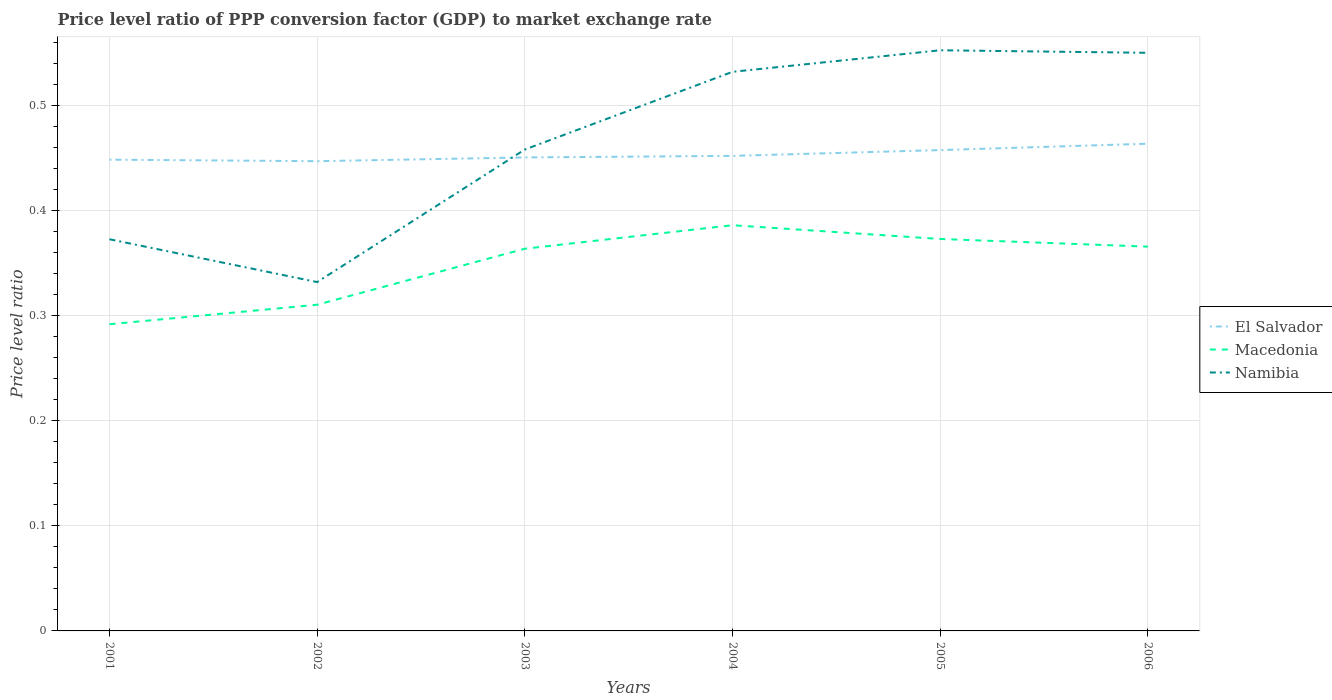Does the line corresponding to Namibia intersect with the line corresponding to El Salvador?
Provide a short and direct response. Yes. Across all years, what is the maximum price level ratio in Macedonia?
Ensure brevity in your answer.  0.29. In which year was the price level ratio in Namibia maximum?
Your answer should be very brief. 2002. What is the total price level ratio in Namibia in the graph?
Make the answer very short. -0.09. What is the difference between the highest and the second highest price level ratio in Macedonia?
Make the answer very short. 0.09. Is the price level ratio in Macedonia strictly greater than the price level ratio in El Salvador over the years?
Provide a short and direct response. Yes. How many years are there in the graph?
Your answer should be compact. 6. Are the values on the major ticks of Y-axis written in scientific E-notation?
Offer a very short reply. No. Does the graph contain grids?
Ensure brevity in your answer.  Yes. How are the legend labels stacked?
Your response must be concise. Vertical. What is the title of the graph?
Ensure brevity in your answer.  Price level ratio of PPP conversion factor (GDP) to market exchange rate. Does "China" appear as one of the legend labels in the graph?
Keep it short and to the point. No. What is the label or title of the Y-axis?
Offer a very short reply. Price level ratio. What is the Price level ratio in El Salvador in 2001?
Your response must be concise. 0.45. What is the Price level ratio in Macedonia in 2001?
Your answer should be very brief. 0.29. What is the Price level ratio of Namibia in 2001?
Provide a short and direct response. 0.37. What is the Price level ratio of El Salvador in 2002?
Ensure brevity in your answer.  0.45. What is the Price level ratio in Macedonia in 2002?
Ensure brevity in your answer.  0.31. What is the Price level ratio of Namibia in 2002?
Provide a succinct answer. 0.33. What is the Price level ratio of El Salvador in 2003?
Your answer should be very brief. 0.45. What is the Price level ratio in Macedonia in 2003?
Keep it short and to the point. 0.36. What is the Price level ratio in Namibia in 2003?
Ensure brevity in your answer.  0.46. What is the Price level ratio in El Salvador in 2004?
Provide a succinct answer. 0.45. What is the Price level ratio in Macedonia in 2004?
Your answer should be very brief. 0.39. What is the Price level ratio of Namibia in 2004?
Offer a very short reply. 0.53. What is the Price level ratio of El Salvador in 2005?
Provide a short and direct response. 0.46. What is the Price level ratio of Macedonia in 2005?
Your answer should be very brief. 0.37. What is the Price level ratio of Namibia in 2005?
Give a very brief answer. 0.55. What is the Price level ratio in El Salvador in 2006?
Provide a succinct answer. 0.46. What is the Price level ratio of Macedonia in 2006?
Your response must be concise. 0.37. What is the Price level ratio in Namibia in 2006?
Keep it short and to the point. 0.55. Across all years, what is the maximum Price level ratio in El Salvador?
Your answer should be compact. 0.46. Across all years, what is the maximum Price level ratio in Macedonia?
Provide a succinct answer. 0.39. Across all years, what is the maximum Price level ratio in Namibia?
Make the answer very short. 0.55. Across all years, what is the minimum Price level ratio of El Salvador?
Your answer should be compact. 0.45. Across all years, what is the minimum Price level ratio of Macedonia?
Offer a very short reply. 0.29. Across all years, what is the minimum Price level ratio of Namibia?
Offer a very short reply. 0.33. What is the total Price level ratio in El Salvador in the graph?
Your answer should be very brief. 2.72. What is the total Price level ratio of Macedonia in the graph?
Your answer should be compact. 2.09. What is the total Price level ratio of Namibia in the graph?
Ensure brevity in your answer.  2.8. What is the difference between the Price level ratio in El Salvador in 2001 and that in 2002?
Your answer should be compact. 0. What is the difference between the Price level ratio in Macedonia in 2001 and that in 2002?
Offer a very short reply. -0.02. What is the difference between the Price level ratio of Namibia in 2001 and that in 2002?
Offer a terse response. 0.04. What is the difference between the Price level ratio of El Salvador in 2001 and that in 2003?
Ensure brevity in your answer.  -0. What is the difference between the Price level ratio in Macedonia in 2001 and that in 2003?
Provide a succinct answer. -0.07. What is the difference between the Price level ratio in Namibia in 2001 and that in 2003?
Offer a terse response. -0.09. What is the difference between the Price level ratio of El Salvador in 2001 and that in 2004?
Your response must be concise. -0. What is the difference between the Price level ratio in Macedonia in 2001 and that in 2004?
Your answer should be very brief. -0.09. What is the difference between the Price level ratio of Namibia in 2001 and that in 2004?
Keep it short and to the point. -0.16. What is the difference between the Price level ratio in El Salvador in 2001 and that in 2005?
Make the answer very short. -0.01. What is the difference between the Price level ratio of Macedonia in 2001 and that in 2005?
Offer a terse response. -0.08. What is the difference between the Price level ratio of Namibia in 2001 and that in 2005?
Keep it short and to the point. -0.18. What is the difference between the Price level ratio in El Salvador in 2001 and that in 2006?
Keep it short and to the point. -0.02. What is the difference between the Price level ratio in Macedonia in 2001 and that in 2006?
Provide a succinct answer. -0.07. What is the difference between the Price level ratio of Namibia in 2001 and that in 2006?
Your response must be concise. -0.18. What is the difference between the Price level ratio of El Salvador in 2002 and that in 2003?
Ensure brevity in your answer.  -0. What is the difference between the Price level ratio of Macedonia in 2002 and that in 2003?
Your answer should be very brief. -0.05. What is the difference between the Price level ratio of Namibia in 2002 and that in 2003?
Your answer should be compact. -0.13. What is the difference between the Price level ratio in El Salvador in 2002 and that in 2004?
Ensure brevity in your answer.  -0.01. What is the difference between the Price level ratio of Macedonia in 2002 and that in 2004?
Give a very brief answer. -0.08. What is the difference between the Price level ratio of Namibia in 2002 and that in 2004?
Provide a succinct answer. -0.2. What is the difference between the Price level ratio in El Salvador in 2002 and that in 2005?
Offer a terse response. -0.01. What is the difference between the Price level ratio of Macedonia in 2002 and that in 2005?
Provide a succinct answer. -0.06. What is the difference between the Price level ratio of Namibia in 2002 and that in 2005?
Your answer should be compact. -0.22. What is the difference between the Price level ratio of El Salvador in 2002 and that in 2006?
Provide a short and direct response. -0.02. What is the difference between the Price level ratio of Macedonia in 2002 and that in 2006?
Your answer should be very brief. -0.06. What is the difference between the Price level ratio of Namibia in 2002 and that in 2006?
Offer a very short reply. -0.22. What is the difference between the Price level ratio in El Salvador in 2003 and that in 2004?
Ensure brevity in your answer.  -0. What is the difference between the Price level ratio of Macedonia in 2003 and that in 2004?
Ensure brevity in your answer.  -0.02. What is the difference between the Price level ratio in Namibia in 2003 and that in 2004?
Give a very brief answer. -0.07. What is the difference between the Price level ratio in El Salvador in 2003 and that in 2005?
Keep it short and to the point. -0.01. What is the difference between the Price level ratio of Macedonia in 2003 and that in 2005?
Your answer should be compact. -0.01. What is the difference between the Price level ratio in Namibia in 2003 and that in 2005?
Give a very brief answer. -0.09. What is the difference between the Price level ratio of El Salvador in 2003 and that in 2006?
Offer a very short reply. -0.01. What is the difference between the Price level ratio in Macedonia in 2003 and that in 2006?
Provide a short and direct response. -0. What is the difference between the Price level ratio of Namibia in 2003 and that in 2006?
Your answer should be very brief. -0.09. What is the difference between the Price level ratio in El Salvador in 2004 and that in 2005?
Offer a very short reply. -0.01. What is the difference between the Price level ratio in Macedonia in 2004 and that in 2005?
Your answer should be compact. 0.01. What is the difference between the Price level ratio of Namibia in 2004 and that in 2005?
Your answer should be very brief. -0.02. What is the difference between the Price level ratio in El Salvador in 2004 and that in 2006?
Provide a succinct answer. -0.01. What is the difference between the Price level ratio of Macedonia in 2004 and that in 2006?
Give a very brief answer. 0.02. What is the difference between the Price level ratio of Namibia in 2004 and that in 2006?
Keep it short and to the point. -0.02. What is the difference between the Price level ratio of El Salvador in 2005 and that in 2006?
Offer a terse response. -0.01. What is the difference between the Price level ratio of Macedonia in 2005 and that in 2006?
Provide a short and direct response. 0.01. What is the difference between the Price level ratio in Namibia in 2005 and that in 2006?
Give a very brief answer. 0. What is the difference between the Price level ratio in El Salvador in 2001 and the Price level ratio in Macedonia in 2002?
Offer a very short reply. 0.14. What is the difference between the Price level ratio of El Salvador in 2001 and the Price level ratio of Namibia in 2002?
Your response must be concise. 0.12. What is the difference between the Price level ratio in Macedonia in 2001 and the Price level ratio in Namibia in 2002?
Your response must be concise. -0.04. What is the difference between the Price level ratio in El Salvador in 2001 and the Price level ratio in Macedonia in 2003?
Offer a very short reply. 0.08. What is the difference between the Price level ratio in El Salvador in 2001 and the Price level ratio in Namibia in 2003?
Offer a very short reply. -0.01. What is the difference between the Price level ratio in Macedonia in 2001 and the Price level ratio in Namibia in 2003?
Offer a very short reply. -0.17. What is the difference between the Price level ratio in El Salvador in 2001 and the Price level ratio in Macedonia in 2004?
Keep it short and to the point. 0.06. What is the difference between the Price level ratio of El Salvador in 2001 and the Price level ratio of Namibia in 2004?
Your answer should be very brief. -0.08. What is the difference between the Price level ratio in Macedonia in 2001 and the Price level ratio in Namibia in 2004?
Provide a short and direct response. -0.24. What is the difference between the Price level ratio in El Salvador in 2001 and the Price level ratio in Macedonia in 2005?
Your answer should be compact. 0.08. What is the difference between the Price level ratio in El Salvador in 2001 and the Price level ratio in Namibia in 2005?
Provide a short and direct response. -0.1. What is the difference between the Price level ratio of Macedonia in 2001 and the Price level ratio of Namibia in 2005?
Provide a short and direct response. -0.26. What is the difference between the Price level ratio of El Salvador in 2001 and the Price level ratio of Macedonia in 2006?
Ensure brevity in your answer.  0.08. What is the difference between the Price level ratio of El Salvador in 2001 and the Price level ratio of Namibia in 2006?
Provide a succinct answer. -0.1. What is the difference between the Price level ratio in Macedonia in 2001 and the Price level ratio in Namibia in 2006?
Offer a terse response. -0.26. What is the difference between the Price level ratio in El Salvador in 2002 and the Price level ratio in Macedonia in 2003?
Offer a very short reply. 0.08. What is the difference between the Price level ratio of El Salvador in 2002 and the Price level ratio of Namibia in 2003?
Give a very brief answer. -0.01. What is the difference between the Price level ratio in Macedonia in 2002 and the Price level ratio in Namibia in 2003?
Make the answer very short. -0.15. What is the difference between the Price level ratio in El Salvador in 2002 and the Price level ratio in Macedonia in 2004?
Ensure brevity in your answer.  0.06. What is the difference between the Price level ratio of El Salvador in 2002 and the Price level ratio of Namibia in 2004?
Provide a short and direct response. -0.09. What is the difference between the Price level ratio of Macedonia in 2002 and the Price level ratio of Namibia in 2004?
Provide a succinct answer. -0.22. What is the difference between the Price level ratio of El Salvador in 2002 and the Price level ratio of Macedonia in 2005?
Your answer should be compact. 0.07. What is the difference between the Price level ratio of El Salvador in 2002 and the Price level ratio of Namibia in 2005?
Your response must be concise. -0.11. What is the difference between the Price level ratio in Macedonia in 2002 and the Price level ratio in Namibia in 2005?
Your answer should be very brief. -0.24. What is the difference between the Price level ratio of El Salvador in 2002 and the Price level ratio of Macedonia in 2006?
Make the answer very short. 0.08. What is the difference between the Price level ratio of El Salvador in 2002 and the Price level ratio of Namibia in 2006?
Ensure brevity in your answer.  -0.1. What is the difference between the Price level ratio in Macedonia in 2002 and the Price level ratio in Namibia in 2006?
Provide a short and direct response. -0.24. What is the difference between the Price level ratio in El Salvador in 2003 and the Price level ratio in Macedonia in 2004?
Ensure brevity in your answer.  0.06. What is the difference between the Price level ratio in El Salvador in 2003 and the Price level ratio in Namibia in 2004?
Give a very brief answer. -0.08. What is the difference between the Price level ratio in Macedonia in 2003 and the Price level ratio in Namibia in 2004?
Your answer should be compact. -0.17. What is the difference between the Price level ratio in El Salvador in 2003 and the Price level ratio in Macedonia in 2005?
Offer a terse response. 0.08. What is the difference between the Price level ratio of El Salvador in 2003 and the Price level ratio of Namibia in 2005?
Your answer should be compact. -0.1. What is the difference between the Price level ratio of Macedonia in 2003 and the Price level ratio of Namibia in 2005?
Offer a very short reply. -0.19. What is the difference between the Price level ratio of El Salvador in 2003 and the Price level ratio of Macedonia in 2006?
Make the answer very short. 0.08. What is the difference between the Price level ratio of El Salvador in 2003 and the Price level ratio of Namibia in 2006?
Keep it short and to the point. -0.1. What is the difference between the Price level ratio of Macedonia in 2003 and the Price level ratio of Namibia in 2006?
Your answer should be compact. -0.19. What is the difference between the Price level ratio in El Salvador in 2004 and the Price level ratio in Macedonia in 2005?
Make the answer very short. 0.08. What is the difference between the Price level ratio in El Salvador in 2004 and the Price level ratio in Namibia in 2005?
Keep it short and to the point. -0.1. What is the difference between the Price level ratio of Macedonia in 2004 and the Price level ratio of Namibia in 2005?
Keep it short and to the point. -0.17. What is the difference between the Price level ratio in El Salvador in 2004 and the Price level ratio in Macedonia in 2006?
Give a very brief answer. 0.09. What is the difference between the Price level ratio of El Salvador in 2004 and the Price level ratio of Namibia in 2006?
Provide a short and direct response. -0.1. What is the difference between the Price level ratio in Macedonia in 2004 and the Price level ratio in Namibia in 2006?
Offer a very short reply. -0.16. What is the difference between the Price level ratio in El Salvador in 2005 and the Price level ratio in Macedonia in 2006?
Your answer should be compact. 0.09. What is the difference between the Price level ratio of El Salvador in 2005 and the Price level ratio of Namibia in 2006?
Your answer should be compact. -0.09. What is the difference between the Price level ratio in Macedonia in 2005 and the Price level ratio in Namibia in 2006?
Your answer should be very brief. -0.18. What is the average Price level ratio of El Salvador per year?
Your answer should be very brief. 0.45. What is the average Price level ratio in Macedonia per year?
Give a very brief answer. 0.35. What is the average Price level ratio of Namibia per year?
Offer a very short reply. 0.47. In the year 2001, what is the difference between the Price level ratio of El Salvador and Price level ratio of Macedonia?
Provide a succinct answer. 0.16. In the year 2001, what is the difference between the Price level ratio in El Salvador and Price level ratio in Namibia?
Provide a succinct answer. 0.08. In the year 2001, what is the difference between the Price level ratio in Macedonia and Price level ratio in Namibia?
Give a very brief answer. -0.08. In the year 2002, what is the difference between the Price level ratio in El Salvador and Price level ratio in Macedonia?
Your response must be concise. 0.14. In the year 2002, what is the difference between the Price level ratio in El Salvador and Price level ratio in Namibia?
Your answer should be very brief. 0.12. In the year 2002, what is the difference between the Price level ratio of Macedonia and Price level ratio of Namibia?
Your response must be concise. -0.02. In the year 2003, what is the difference between the Price level ratio in El Salvador and Price level ratio in Macedonia?
Your response must be concise. 0.09. In the year 2003, what is the difference between the Price level ratio of El Salvador and Price level ratio of Namibia?
Provide a short and direct response. -0.01. In the year 2003, what is the difference between the Price level ratio in Macedonia and Price level ratio in Namibia?
Offer a very short reply. -0.09. In the year 2004, what is the difference between the Price level ratio of El Salvador and Price level ratio of Macedonia?
Give a very brief answer. 0.07. In the year 2004, what is the difference between the Price level ratio in El Salvador and Price level ratio in Namibia?
Ensure brevity in your answer.  -0.08. In the year 2004, what is the difference between the Price level ratio of Macedonia and Price level ratio of Namibia?
Ensure brevity in your answer.  -0.15. In the year 2005, what is the difference between the Price level ratio in El Salvador and Price level ratio in Macedonia?
Your answer should be compact. 0.08. In the year 2005, what is the difference between the Price level ratio of El Salvador and Price level ratio of Namibia?
Offer a very short reply. -0.1. In the year 2005, what is the difference between the Price level ratio of Macedonia and Price level ratio of Namibia?
Ensure brevity in your answer.  -0.18. In the year 2006, what is the difference between the Price level ratio of El Salvador and Price level ratio of Macedonia?
Your answer should be very brief. 0.1. In the year 2006, what is the difference between the Price level ratio of El Salvador and Price level ratio of Namibia?
Offer a terse response. -0.09. In the year 2006, what is the difference between the Price level ratio in Macedonia and Price level ratio in Namibia?
Keep it short and to the point. -0.18. What is the ratio of the Price level ratio in El Salvador in 2001 to that in 2002?
Provide a succinct answer. 1. What is the ratio of the Price level ratio in Macedonia in 2001 to that in 2002?
Your answer should be very brief. 0.94. What is the ratio of the Price level ratio of Namibia in 2001 to that in 2002?
Provide a short and direct response. 1.12. What is the ratio of the Price level ratio of El Salvador in 2001 to that in 2003?
Keep it short and to the point. 1. What is the ratio of the Price level ratio of Macedonia in 2001 to that in 2003?
Your answer should be very brief. 0.8. What is the ratio of the Price level ratio of Namibia in 2001 to that in 2003?
Your answer should be very brief. 0.81. What is the ratio of the Price level ratio of Macedonia in 2001 to that in 2004?
Provide a short and direct response. 0.76. What is the ratio of the Price level ratio in Namibia in 2001 to that in 2004?
Make the answer very short. 0.7. What is the ratio of the Price level ratio of El Salvador in 2001 to that in 2005?
Offer a very short reply. 0.98. What is the ratio of the Price level ratio in Macedonia in 2001 to that in 2005?
Keep it short and to the point. 0.78. What is the ratio of the Price level ratio in Namibia in 2001 to that in 2005?
Your answer should be very brief. 0.67. What is the ratio of the Price level ratio in El Salvador in 2001 to that in 2006?
Your answer should be very brief. 0.97. What is the ratio of the Price level ratio in Macedonia in 2001 to that in 2006?
Offer a terse response. 0.8. What is the ratio of the Price level ratio of Namibia in 2001 to that in 2006?
Keep it short and to the point. 0.68. What is the ratio of the Price level ratio of Macedonia in 2002 to that in 2003?
Keep it short and to the point. 0.85. What is the ratio of the Price level ratio in Namibia in 2002 to that in 2003?
Keep it short and to the point. 0.72. What is the ratio of the Price level ratio of Macedonia in 2002 to that in 2004?
Your answer should be compact. 0.8. What is the ratio of the Price level ratio of Namibia in 2002 to that in 2004?
Your response must be concise. 0.62. What is the ratio of the Price level ratio of El Salvador in 2002 to that in 2005?
Ensure brevity in your answer.  0.98. What is the ratio of the Price level ratio in Macedonia in 2002 to that in 2005?
Make the answer very short. 0.83. What is the ratio of the Price level ratio of Namibia in 2002 to that in 2005?
Your response must be concise. 0.6. What is the ratio of the Price level ratio of El Salvador in 2002 to that in 2006?
Give a very brief answer. 0.96. What is the ratio of the Price level ratio in Macedonia in 2002 to that in 2006?
Give a very brief answer. 0.85. What is the ratio of the Price level ratio in Namibia in 2002 to that in 2006?
Offer a terse response. 0.6. What is the ratio of the Price level ratio of El Salvador in 2003 to that in 2004?
Your answer should be compact. 1. What is the ratio of the Price level ratio in Macedonia in 2003 to that in 2004?
Provide a succinct answer. 0.94. What is the ratio of the Price level ratio in Namibia in 2003 to that in 2004?
Your response must be concise. 0.86. What is the ratio of the Price level ratio in El Salvador in 2003 to that in 2005?
Offer a terse response. 0.98. What is the ratio of the Price level ratio in Macedonia in 2003 to that in 2005?
Your answer should be compact. 0.98. What is the ratio of the Price level ratio in Namibia in 2003 to that in 2005?
Your answer should be very brief. 0.83. What is the ratio of the Price level ratio of El Salvador in 2003 to that in 2006?
Your answer should be very brief. 0.97. What is the ratio of the Price level ratio of Namibia in 2003 to that in 2006?
Provide a short and direct response. 0.83. What is the ratio of the Price level ratio of El Salvador in 2004 to that in 2005?
Provide a succinct answer. 0.99. What is the ratio of the Price level ratio in Macedonia in 2004 to that in 2005?
Offer a very short reply. 1.04. What is the ratio of the Price level ratio of Namibia in 2004 to that in 2005?
Your answer should be compact. 0.96. What is the ratio of the Price level ratio in El Salvador in 2004 to that in 2006?
Provide a short and direct response. 0.97. What is the ratio of the Price level ratio of Macedonia in 2004 to that in 2006?
Provide a short and direct response. 1.06. What is the ratio of the Price level ratio of Namibia in 2004 to that in 2006?
Offer a terse response. 0.97. What is the ratio of the Price level ratio in El Salvador in 2005 to that in 2006?
Give a very brief answer. 0.99. What is the ratio of the Price level ratio in Macedonia in 2005 to that in 2006?
Offer a very short reply. 1.02. What is the ratio of the Price level ratio in Namibia in 2005 to that in 2006?
Provide a succinct answer. 1. What is the difference between the highest and the second highest Price level ratio of El Salvador?
Keep it short and to the point. 0.01. What is the difference between the highest and the second highest Price level ratio in Macedonia?
Give a very brief answer. 0.01. What is the difference between the highest and the second highest Price level ratio in Namibia?
Provide a succinct answer. 0. What is the difference between the highest and the lowest Price level ratio of El Salvador?
Give a very brief answer. 0.02. What is the difference between the highest and the lowest Price level ratio of Macedonia?
Make the answer very short. 0.09. What is the difference between the highest and the lowest Price level ratio of Namibia?
Provide a short and direct response. 0.22. 